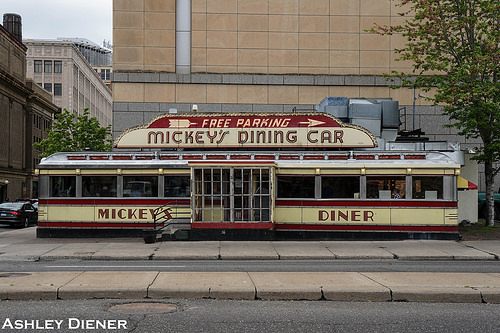<image>
Is there a sign on the car? Yes. Looking at the image, I can see the sign is positioned on top of the car, with the car providing support. Is there a diner in front of the car? No. The diner is not in front of the car. The spatial positioning shows a different relationship between these objects. 